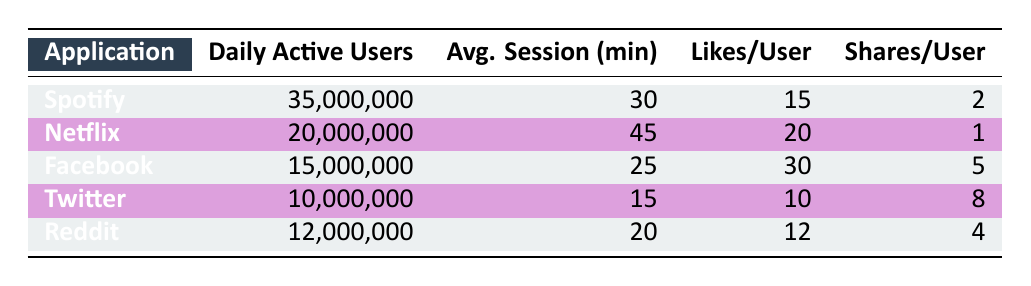What application has the highest number of daily active users? By examining the "Daily Active Users" column, we find that Spotify has 35,000,000 users, which is higher than all the other applications listed in the table.
Answer: Spotify How many likes per user does Facebook receive? Referring to the "Likes/User" column, Facebook has 30 likes per user, which is explicitly stated in the table.
Answer: 30 What is the average session duration for Netflix? The table shows that Netflix has an average session duration of 45 minutes, which is directly listed under the "Avg. Session (min)" column.
Answer: 45 Which application has fewer daily active users than Spotify but more than Reddit? By reviewing the "Daily Active Users" column, we see that Netflix has 20,000,000 daily active users (more than Reddit's 12,000,000) and fewer than Spotify’s 35,000,000.
Answer: Netflix What is the total number of likes per user for all applications combined? Summing up the likes per user from each application gives: 15 (Spotify) + 20 (Netflix) + 30 (Facebook) + 10 (Twitter) + 12 (Reddit) = 87. This total is derived from aggregating all the values in the "Likes/User" column.
Answer: 87 Does Twitter have the lowest average session duration among all applications? Looking at the "Avg. Session (min)" column, Twitter has an average session duration of 15 minutes, which is distinctly less than all other applications listed.
Answer: Yes What is the difference in daily active users between Spotify and Twitter? To find the difference, we subtract Twitter’s daily active users (10,000,000) from Spotify’s (35,000,000). Thus, the difference is 35,000,000 - 10,000,000 = 25,000,000.
Answer: 25,000,000 Which application has the highest shares per user, and what is that number? By reviewing the "Shares/User" column, Facebook has 5 shares per user, which is the highest compared to the other applications listed in the table.
Answer: Facebook, 5 What percentage of the daily active users of Facebook compared to Spotify? First, we calculate the percentage by taking the daily active users of Facebook (15,000,000) and dividing it by that of Spotify (35,000,000), then multiplying by 100: (15,000,000 / 35,000,000) * 100 = 42.86%.
Answer: 42.86% 